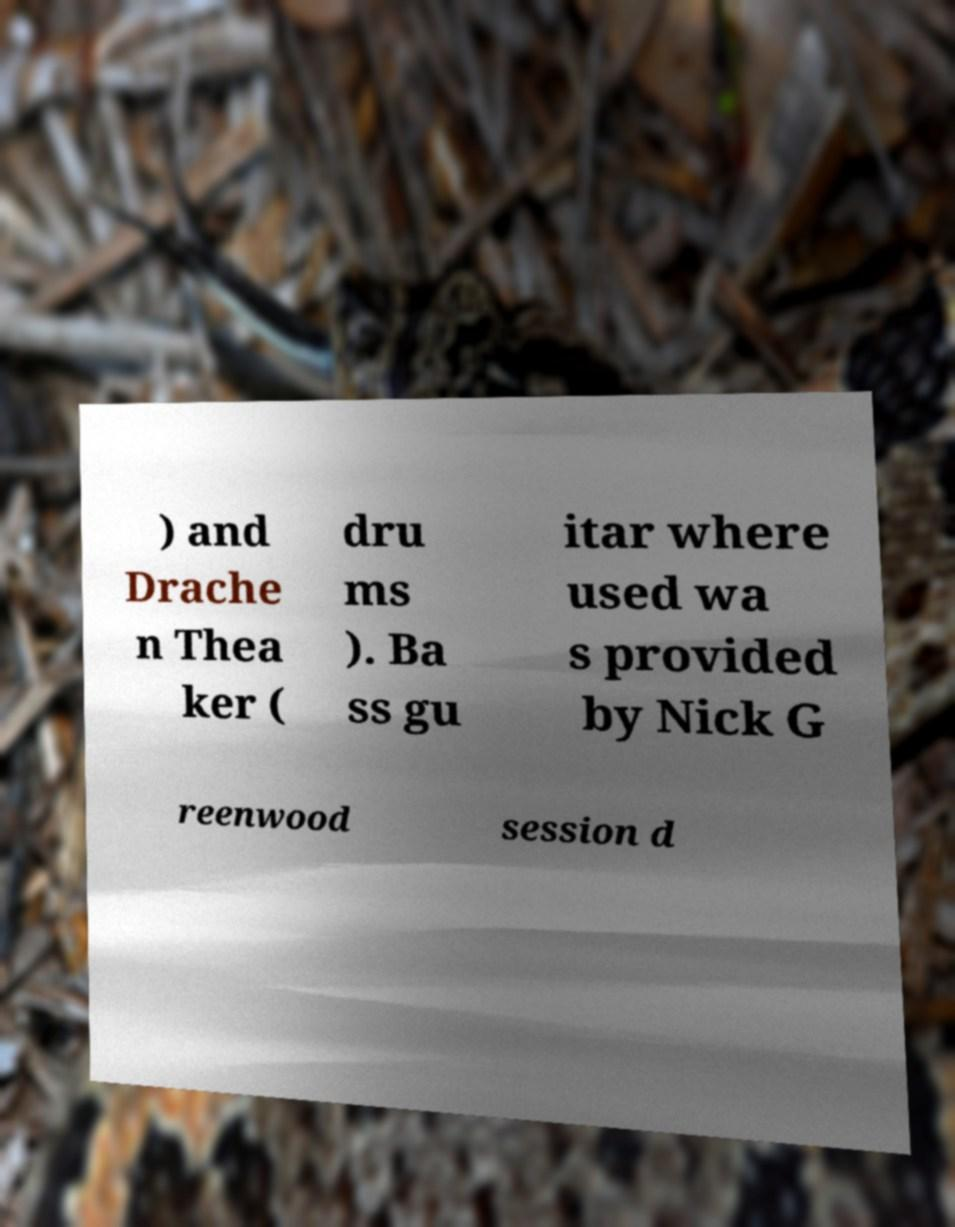What messages or text are displayed in this image? I need them in a readable, typed format. ) and Drache n Thea ker ( dru ms ). Ba ss gu itar where used wa s provided by Nick G reenwood session d 